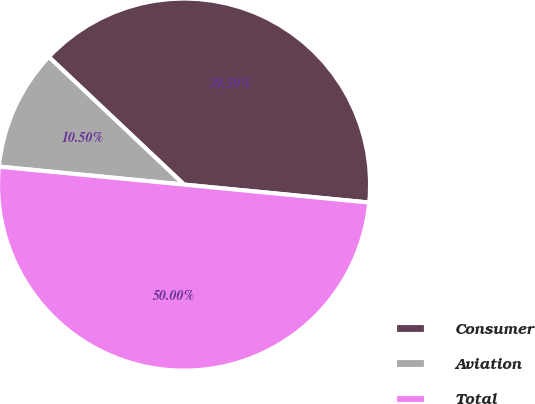<chart> <loc_0><loc_0><loc_500><loc_500><pie_chart><fcel>Consumer<fcel>Aviation<fcel>Total<nl><fcel>39.5%<fcel>10.5%<fcel>50.0%<nl></chart> 